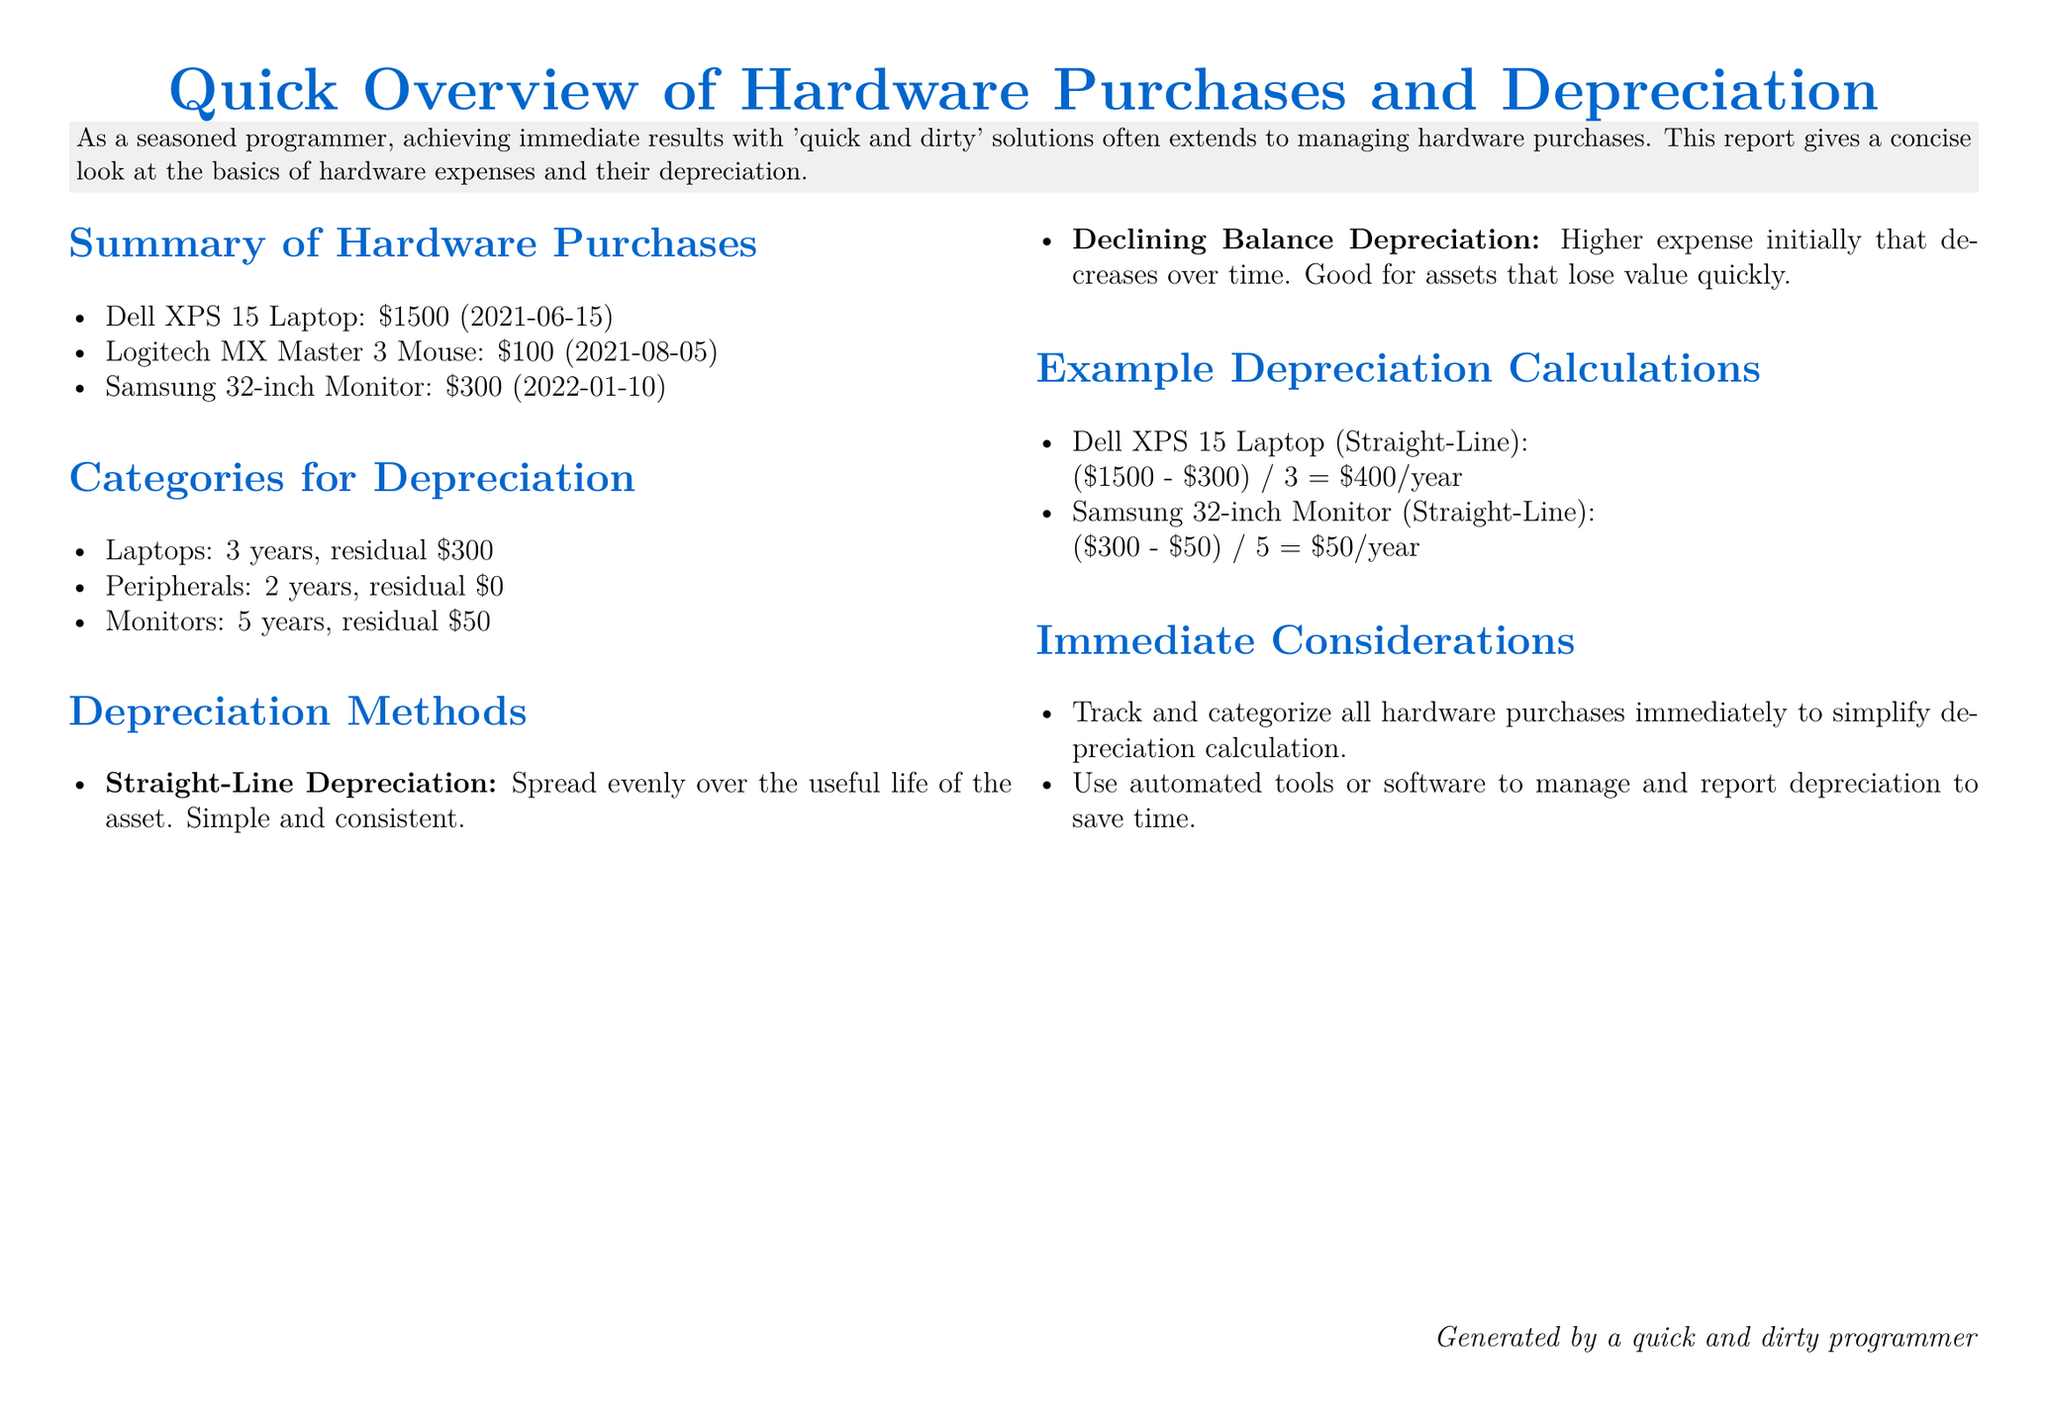What is the purchase date of the Dell XPS 15 Laptop? The purchase date can be found in the summary of hardware purchases under the Dell XPS 15 Laptop item.
Answer: 2021-06-15 What is the residual value of laptops for depreciation? The residual value for laptops is stated in the categories for depreciation section of the document.
Answer: $300 How much does the Samsung 32-inch Monitor depreciate per year? The yearly depreciation is calculated based on the example depreciation calculations section for the Samsung monitor.
Answer: $50/year What depreciation method spreads costs evenly over the asset's life? This method is mentioned in the depreciation methods section where it describes straight-line depreciation.
Answer: Straight-Line Depreciation Which peripheral is listed with a purchase price of $100? The list of hardware purchases includes the Logitech MX Master 3 Mouse with this price.
Answer: Logitech MX Master 3 Mouse What is the useful life of a monitor for depreciation? The period is specified in the categories for depreciation section for monitors.
Answer: 5 years How many hardware purchases are listed in the report? The summary of hardware purchases section provides the count of items listed.
Answer: 3 What is a recommended tool for managing depreciation? The immediate considerations section suggests tools for this purpose.
Answer: Automated tools 